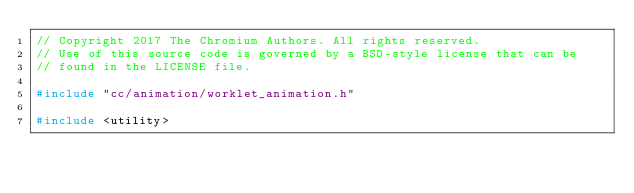Convert code to text. <code><loc_0><loc_0><loc_500><loc_500><_C++_>// Copyright 2017 The Chromium Authors. All rights reserved.
// Use of this source code is governed by a BSD-style license that can be
// found in the LICENSE file.

#include "cc/animation/worklet_animation.h"

#include <utility></code> 